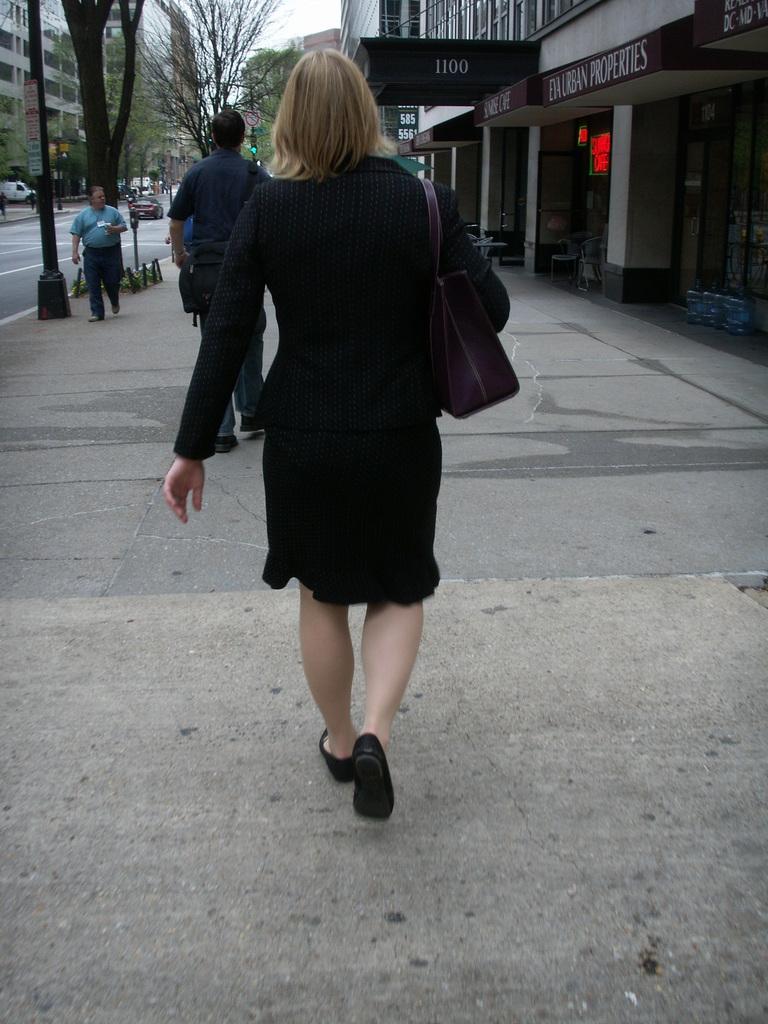Please provide a concise description of this image. In this image I can see group of people walking. In front the person is wearing black color dress, background I can see few buildings in gray and white color, trees in green color. I can also see few vehicles and the sky is in white color. 